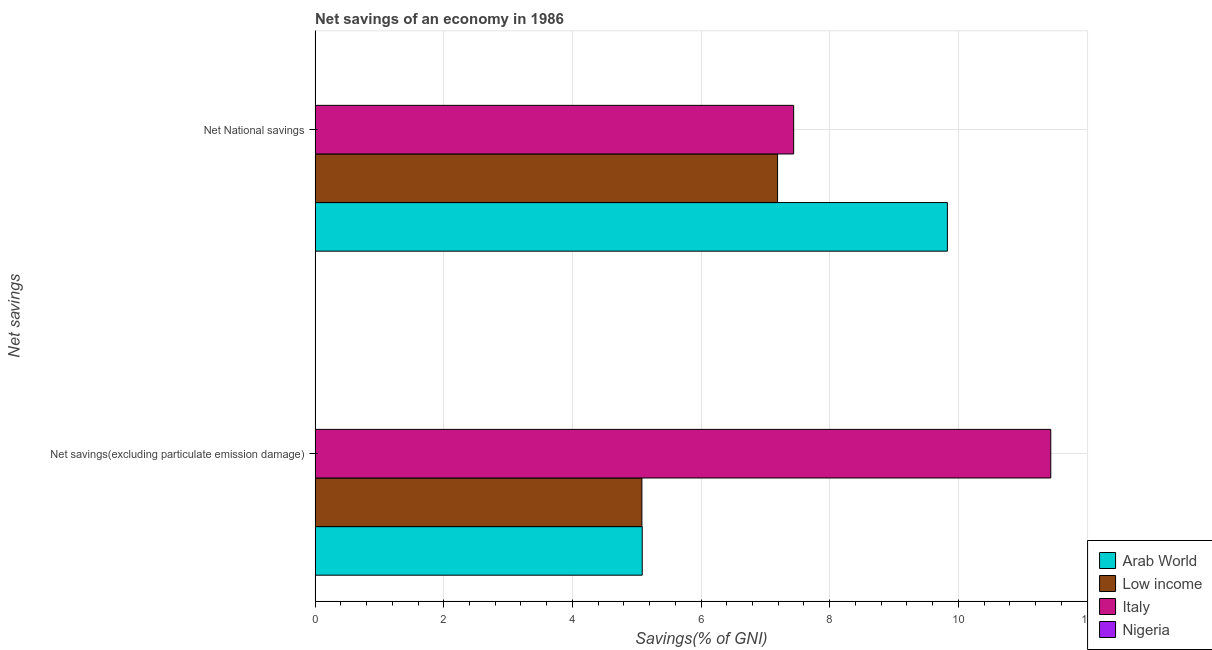How many groups of bars are there?
Offer a terse response. 2. Are the number of bars on each tick of the Y-axis equal?
Offer a terse response. Yes. How many bars are there on the 1st tick from the bottom?
Offer a very short reply. 3. What is the label of the 2nd group of bars from the top?
Keep it short and to the point. Net savings(excluding particulate emission damage). What is the net savings(excluding particulate emission damage) in Italy?
Offer a very short reply. 11.44. Across all countries, what is the maximum net national savings?
Your answer should be very brief. 9.83. Across all countries, what is the minimum net savings(excluding particulate emission damage)?
Your answer should be compact. 0. In which country was the net savings(excluding particulate emission damage) maximum?
Make the answer very short. Italy. What is the total net national savings in the graph?
Your answer should be very brief. 24.46. What is the difference between the net savings(excluding particulate emission damage) in Arab World and that in Italy?
Provide a succinct answer. -6.35. What is the difference between the net national savings in Nigeria and the net savings(excluding particulate emission damage) in Low income?
Your answer should be very brief. -5.08. What is the average net national savings per country?
Offer a terse response. 6.11. What is the difference between the net savings(excluding particulate emission damage) and net national savings in Italy?
Make the answer very short. 4. In how many countries, is the net national savings greater than 8.4 %?
Keep it short and to the point. 1. What is the ratio of the net national savings in Low income to that in Italy?
Ensure brevity in your answer.  0.97. Is the net savings(excluding particulate emission damage) in Arab World less than that in Italy?
Ensure brevity in your answer.  Yes. Are all the bars in the graph horizontal?
Provide a succinct answer. Yes. How many countries are there in the graph?
Give a very brief answer. 4. What is the difference between two consecutive major ticks on the X-axis?
Your response must be concise. 2. Are the values on the major ticks of X-axis written in scientific E-notation?
Make the answer very short. No. Does the graph contain grids?
Make the answer very short. Yes. How are the legend labels stacked?
Give a very brief answer. Vertical. What is the title of the graph?
Offer a very short reply. Net savings of an economy in 1986. What is the label or title of the X-axis?
Ensure brevity in your answer.  Savings(% of GNI). What is the label or title of the Y-axis?
Keep it short and to the point. Net savings. What is the Savings(% of GNI) in Arab World in Net savings(excluding particulate emission damage)?
Your answer should be very brief. 5.09. What is the Savings(% of GNI) of Low income in Net savings(excluding particulate emission damage)?
Your answer should be compact. 5.08. What is the Savings(% of GNI) of Italy in Net savings(excluding particulate emission damage)?
Your answer should be compact. 11.44. What is the Savings(% of GNI) in Arab World in Net National savings?
Provide a succinct answer. 9.83. What is the Savings(% of GNI) of Low income in Net National savings?
Give a very brief answer. 7.19. What is the Savings(% of GNI) in Italy in Net National savings?
Offer a terse response. 7.44. Across all Net savings, what is the maximum Savings(% of GNI) in Arab World?
Provide a short and direct response. 9.83. Across all Net savings, what is the maximum Savings(% of GNI) of Low income?
Give a very brief answer. 7.19. Across all Net savings, what is the maximum Savings(% of GNI) in Italy?
Your answer should be very brief. 11.44. Across all Net savings, what is the minimum Savings(% of GNI) in Arab World?
Offer a very short reply. 5.09. Across all Net savings, what is the minimum Savings(% of GNI) in Low income?
Offer a very short reply. 5.08. Across all Net savings, what is the minimum Savings(% of GNI) in Italy?
Provide a short and direct response. 7.44. What is the total Savings(% of GNI) in Arab World in the graph?
Ensure brevity in your answer.  14.91. What is the total Savings(% of GNI) of Low income in the graph?
Your response must be concise. 12.27. What is the total Savings(% of GNI) in Italy in the graph?
Provide a short and direct response. 18.88. What is the total Savings(% of GNI) of Nigeria in the graph?
Offer a very short reply. 0. What is the difference between the Savings(% of GNI) of Arab World in Net savings(excluding particulate emission damage) and that in Net National savings?
Offer a terse response. -4.74. What is the difference between the Savings(% of GNI) of Low income in Net savings(excluding particulate emission damage) and that in Net National savings?
Give a very brief answer. -2.11. What is the difference between the Savings(% of GNI) in Italy in Net savings(excluding particulate emission damage) and that in Net National savings?
Your answer should be compact. 4. What is the difference between the Savings(% of GNI) in Arab World in Net savings(excluding particulate emission damage) and the Savings(% of GNI) in Low income in Net National savings?
Your response must be concise. -2.1. What is the difference between the Savings(% of GNI) in Arab World in Net savings(excluding particulate emission damage) and the Savings(% of GNI) in Italy in Net National savings?
Provide a short and direct response. -2.35. What is the difference between the Savings(% of GNI) of Low income in Net savings(excluding particulate emission damage) and the Savings(% of GNI) of Italy in Net National savings?
Offer a terse response. -2.36. What is the average Savings(% of GNI) of Arab World per Net savings?
Your response must be concise. 7.46. What is the average Savings(% of GNI) of Low income per Net savings?
Make the answer very short. 6.13. What is the average Savings(% of GNI) of Italy per Net savings?
Your answer should be very brief. 9.44. What is the difference between the Savings(% of GNI) of Arab World and Savings(% of GNI) of Low income in Net savings(excluding particulate emission damage)?
Provide a short and direct response. 0.01. What is the difference between the Savings(% of GNI) of Arab World and Savings(% of GNI) of Italy in Net savings(excluding particulate emission damage)?
Give a very brief answer. -6.35. What is the difference between the Savings(% of GNI) of Low income and Savings(% of GNI) of Italy in Net savings(excluding particulate emission damage)?
Offer a very short reply. -6.36. What is the difference between the Savings(% of GNI) of Arab World and Savings(% of GNI) of Low income in Net National savings?
Your response must be concise. 2.64. What is the difference between the Savings(% of GNI) of Arab World and Savings(% of GNI) of Italy in Net National savings?
Make the answer very short. 2.39. What is the difference between the Savings(% of GNI) in Low income and Savings(% of GNI) in Italy in Net National savings?
Make the answer very short. -0.25. What is the ratio of the Savings(% of GNI) of Arab World in Net savings(excluding particulate emission damage) to that in Net National savings?
Offer a very short reply. 0.52. What is the ratio of the Savings(% of GNI) in Low income in Net savings(excluding particulate emission damage) to that in Net National savings?
Make the answer very short. 0.71. What is the ratio of the Savings(% of GNI) in Italy in Net savings(excluding particulate emission damage) to that in Net National savings?
Your response must be concise. 1.54. What is the difference between the highest and the second highest Savings(% of GNI) in Arab World?
Offer a very short reply. 4.74. What is the difference between the highest and the second highest Savings(% of GNI) in Low income?
Your answer should be compact. 2.11. What is the difference between the highest and the second highest Savings(% of GNI) of Italy?
Provide a short and direct response. 4. What is the difference between the highest and the lowest Savings(% of GNI) of Arab World?
Your answer should be compact. 4.74. What is the difference between the highest and the lowest Savings(% of GNI) of Low income?
Your answer should be very brief. 2.11. What is the difference between the highest and the lowest Savings(% of GNI) in Italy?
Provide a succinct answer. 4. 